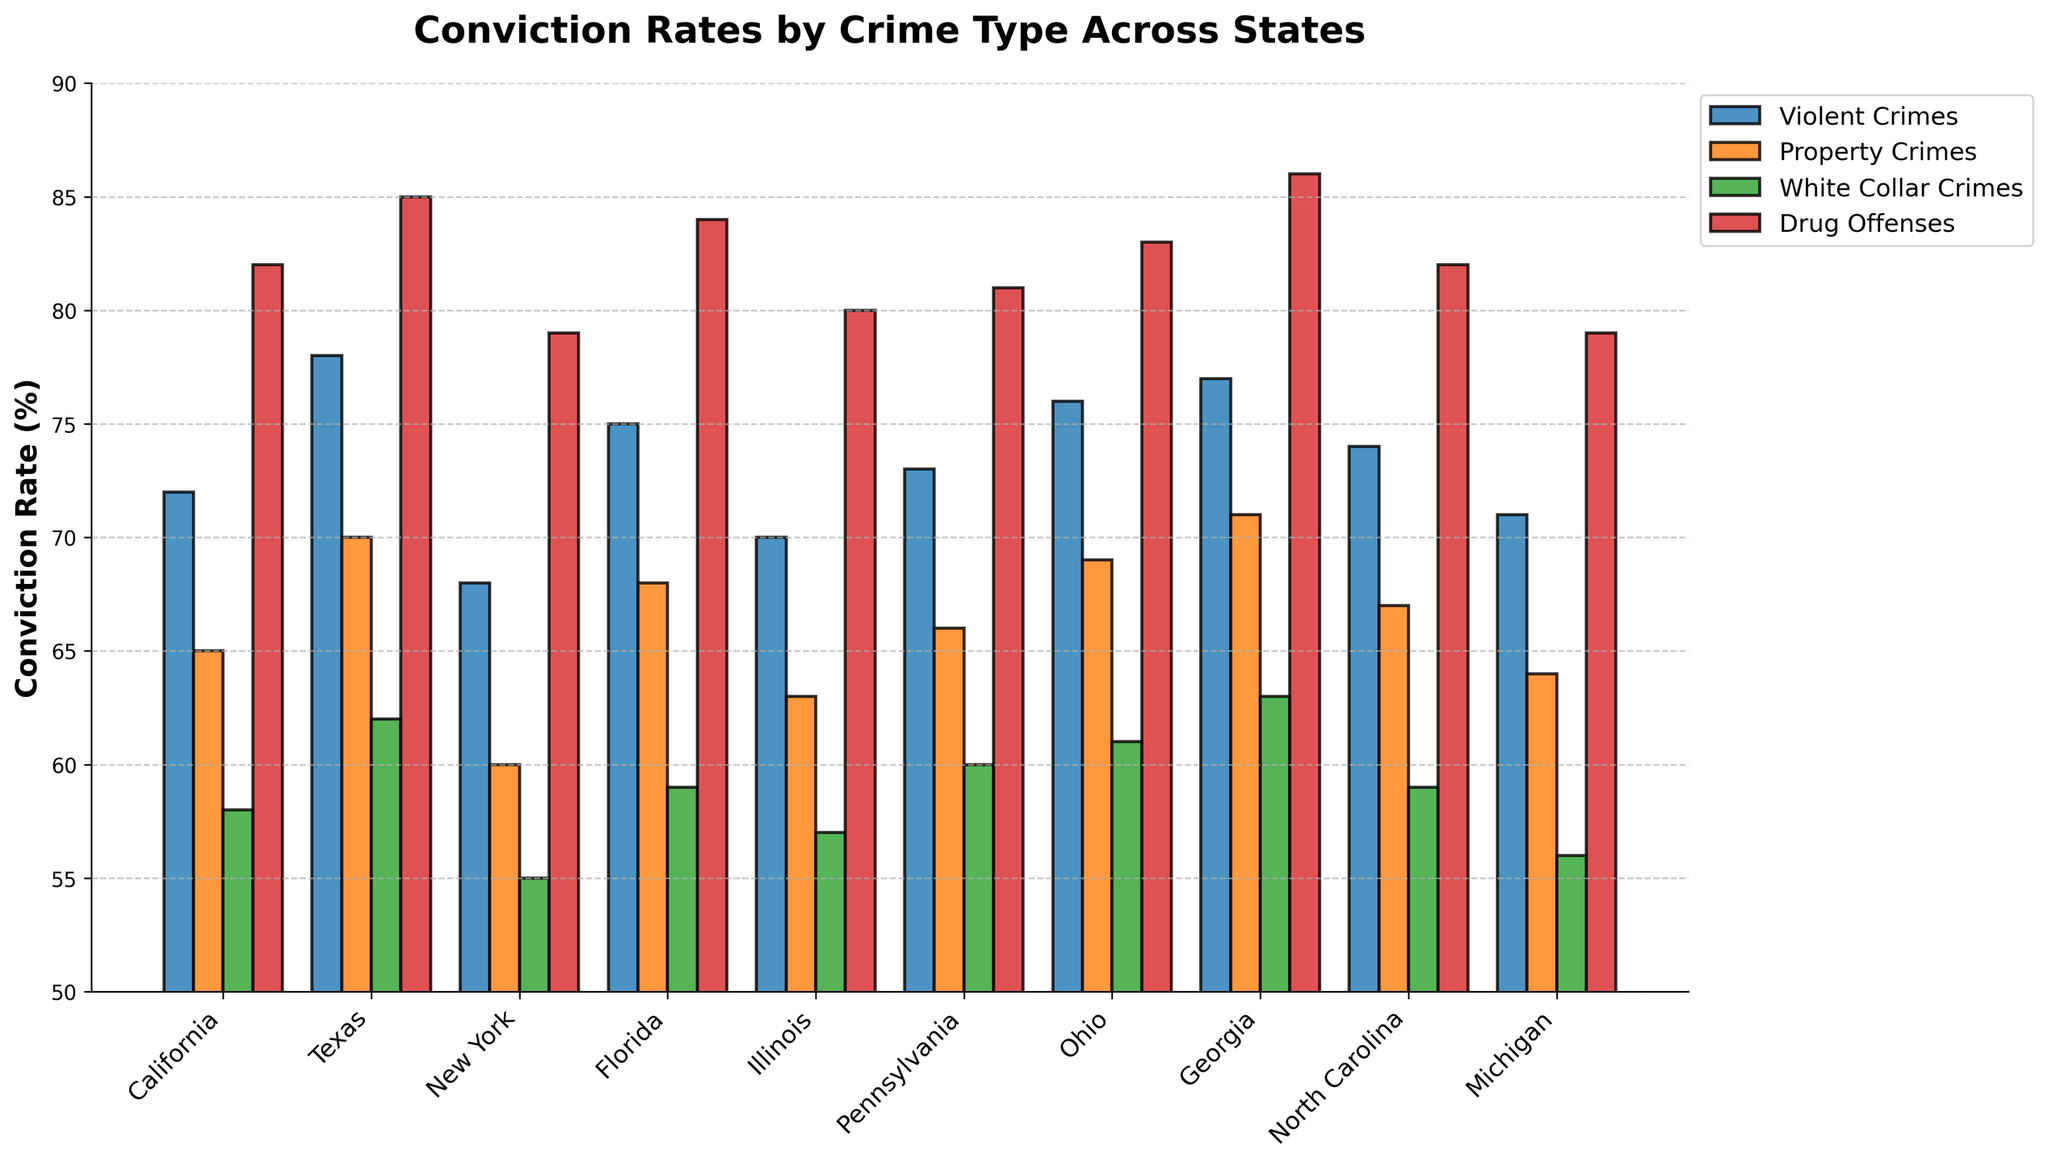Which state has the highest conviction rate for drug offenses? The tallest bar in the "Drug Offenses" category represents the state with the highest conviction rate. The state is Georgia with an 86% conviction rate.
Answer: Georgia Which crime type in California has the second lowest conviction rate? Observe the bars for California. The second lowest bar is for "White Collar Crimes" with a 58% conviction rate.
Answer: White Collar Crimes What is the difference in conviction rates for violent crimes between Texas and New York? The bar height for Texas in the "Violent Crimes" category is 78%, and for New York, it is 68%. The difference is 78% - 68% = 10%.
Answer: 10% Compare the conviction rates for white collar crimes between Ohio and Florida. Which state has a higher rate? The bar for Ohio in the "White Collar Crimes" category is 61%, and for Florida, it is 59%. Ohio has a higher conviction rate by 2%.
Answer: Ohio Calculate the average conviction rate for violent crimes across all the states. Sum all the conviction rates for violent crimes and divide by the number of states: (72 + 78 + 68 + 75 + 70 + 73 + 76 + 77 + 74 + 71) / 10 = 73.4%.
Answer: 73.4% In which state are the conviction rates for property crimes and drug offenses both above 80%? Check for states where both bars in the "Property Crimes" and "Drug Offenses" categories exceed 80%. Georgia has property crimes at 71% but drug offenses at 86%. While Ohio has these categories at 69% and 83%, and Texas at 70% and 85%, none meet both conditions simultaneously above 80%. Hence, no state fits this criterion.
Answer: None Which state has the smallest range in conviction rates across all crime types? Find the difference between the highest and lowest conviction rates within each state. California: 82%-58%=24%, Texas: 85%-62%=23%, New York: 79%-55%=24%, Florida: 84%-59%=25%, Illinois: 80%-57%=23%, Pennsylvania: 81%-60%=21%, Ohio: 83%-61%=22%, Georgia: 86%-63%=23%, North Carolina: 82%-59%=23%, Michigan: 79%-56%=23%. Pennsylvania has the smallest range of 21%.
Answer: Pennsylvania What percentage of states have a property crime conviction rate of 65% or higher? Count the number of states with conviction rates of 65% or higher for property crimes, then divide by the total number of states and multiply by 100. States: California (65%), Texas (70%), Florida (68%), Pennsylvania (66%), Ohio (69%), Georgia (71%), North Carolina (67%), Michigan (64%). 8 states out of 10 have 65% or higher, so (8/10) * 100 = 80%.
Answer: 80% 